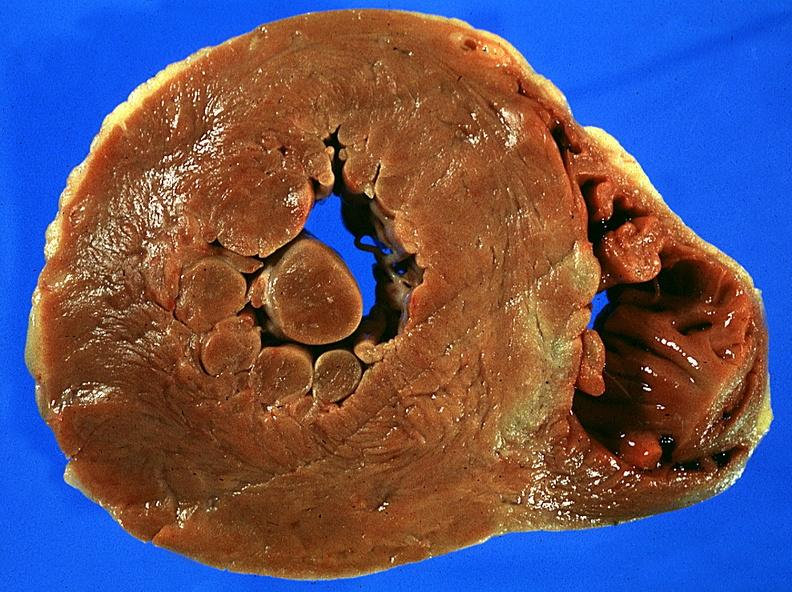what is present?
Answer the question using a single word or phrase. Cardiovascular 